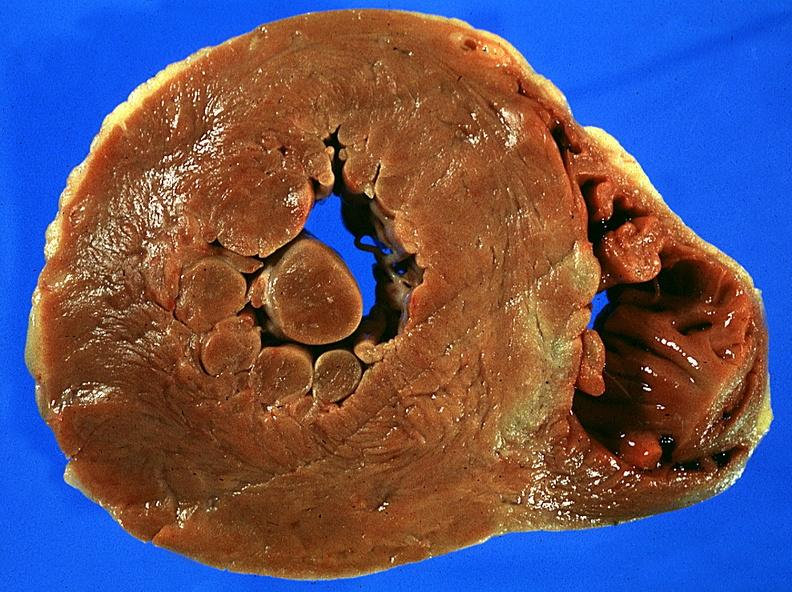what is present?
Answer the question using a single word or phrase. Cardiovascular 